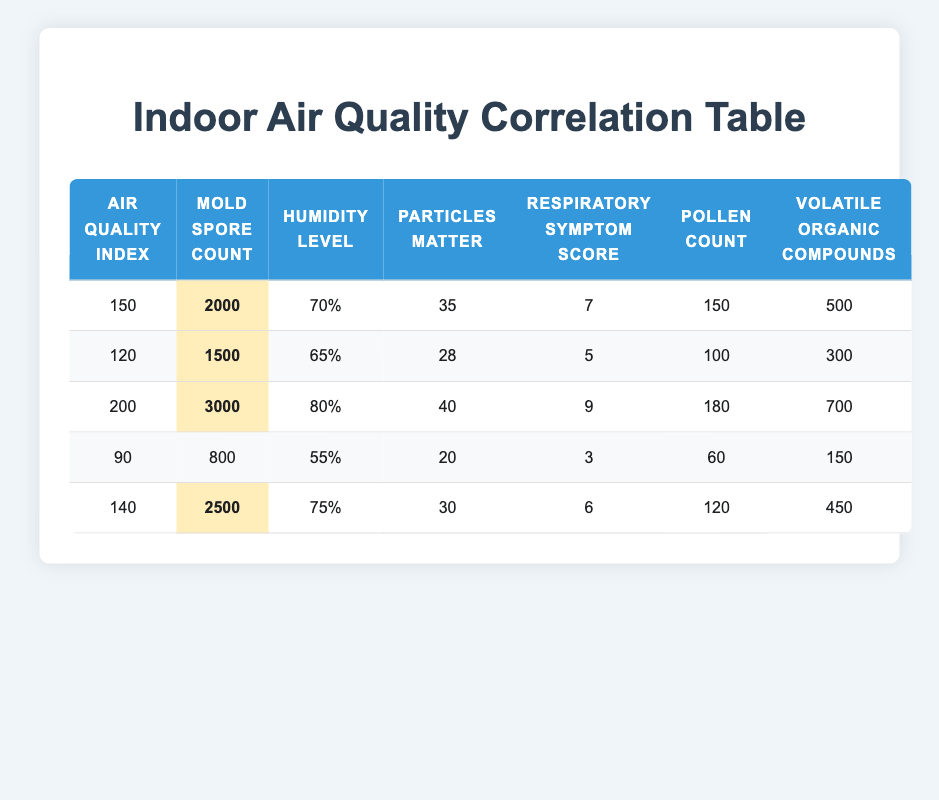What is the maximum Mold Spore Count recorded? The Mold Spore Counts in the table are 2000, 1500, 3000, 800, 2500. The highest value among these is 3000.
Answer: 3000 What is the average Air Quality Index across all data points? The Air Quality Index values are 150, 120, 200, 90, 140. To find the average, sum these values (150 + 120 + 200 + 90 + 140 = 700) and divide by the number of data points (700/5 = 140).
Answer: 140 Is there a correlation between high Mold Spore Count and a high Respiratory Symptom Score? By comparing the rows with high Mold Spore Counts (2000, 1500, 3000, 2500), we see their corresponding Respiratory Symptom Scores (7, 5, 9, 6). Scores are indeed higher with increased spore counts, indicating a possible correlation.
Answer: Yes What is the difference in the Respiratory Symptom Score between the highest and the lowest Air Quality Index? The highest Air Quality Index is 200 with a Respiratory Symptom Score of 9. The lowest Air Quality Index is 90 with a score of 3. The difference is calculated as (9 - 3 = 6).
Answer: 6 Could you confirm if all recorded Humidity Levels are above 50%? The Humidity Levels listed are 70%, 65%, 80%, 55%, and 75%. Since all are above 50%, the statement is true.
Answer: Yes What’s the overall highest value in Volatile Organic Compounds? The Volatile Organic Compounds values recorded are 500, 300, 700, 150, and 450. Among these, 700 is the highest value.
Answer: 700 How many data points have a Respiratory Symptom Score of 6 or higher? The Respiratory Symptom Scores are 7, 5, 9, 3, and 6. Scores of 6 or higher are 7, 9, and 6, totaling 3 data points.
Answer: 3 What is the average Pollen Count for the samples in the table? The Pollen Counts are 150, 100, 180, 60, and 120. Summing these numbers gives (150 + 100 + 180 + 60 + 120 = 610), and dividing by 5 provides the average (610/5 = 122).
Answer: 122 Is the Humidity Level associated with higher Mold Spore Counts? Analyzing the data shows that at high Humidity Levels of 80% and 75%, the Mold Spore Counts are 3000 and 2500, respectively. Lower humidity levels have lower counts, indicating an association.
Answer: Yes 